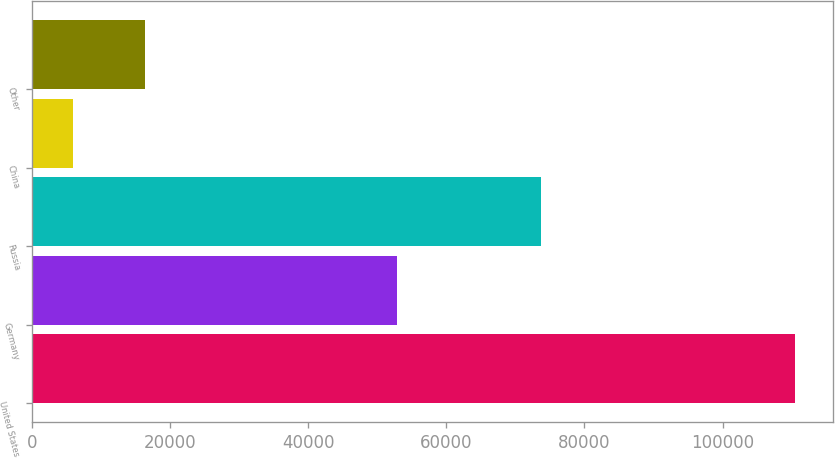Convert chart to OTSL. <chart><loc_0><loc_0><loc_500><loc_500><bar_chart><fcel>United States<fcel>Germany<fcel>Russia<fcel>China<fcel>Other<nl><fcel>110441<fcel>52791<fcel>73747<fcel>5895<fcel>16349.6<nl></chart> 